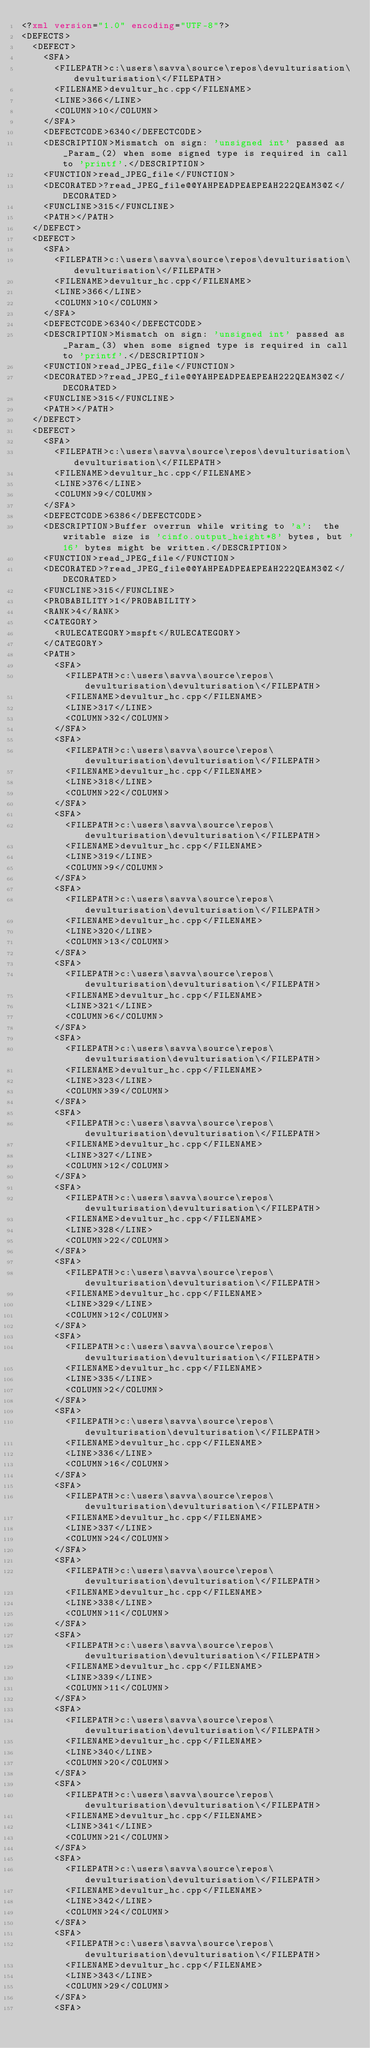<code> <loc_0><loc_0><loc_500><loc_500><_XML_><?xml version="1.0" encoding="UTF-8"?>
<DEFECTS>
  <DEFECT>
    <SFA>
      <FILEPATH>c:\users\savva\source\repos\devulturisation\devulturisation\</FILEPATH>
      <FILENAME>devultur_hc.cpp</FILENAME>
      <LINE>366</LINE>
      <COLUMN>10</COLUMN>
    </SFA>
    <DEFECTCODE>6340</DEFECTCODE>
    <DESCRIPTION>Mismatch on sign: 'unsigned int' passed as _Param_(2) when some signed type is required in call to 'printf'.</DESCRIPTION>
    <FUNCTION>read_JPEG_file</FUNCTION>
    <DECORATED>?read_JPEG_file@@YAHPEADPEAEPEAH222QEAM3@Z</DECORATED>
    <FUNCLINE>315</FUNCLINE>
    <PATH></PATH>
  </DEFECT>
  <DEFECT>
    <SFA>
      <FILEPATH>c:\users\savva\source\repos\devulturisation\devulturisation\</FILEPATH>
      <FILENAME>devultur_hc.cpp</FILENAME>
      <LINE>366</LINE>
      <COLUMN>10</COLUMN>
    </SFA>
    <DEFECTCODE>6340</DEFECTCODE>
    <DESCRIPTION>Mismatch on sign: 'unsigned int' passed as _Param_(3) when some signed type is required in call to 'printf'.</DESCRIPTION>
    <FUNCTION>read_JPEG_file</FUNCTION>
    <DECORATED>?read_JPEG_file@@YAHPEADPEAEPEAH222QEAM3@Z</DECORATED>
    <FUNCLINE>315</FUNCLINE>
    <PATH></PATH>
  </DEFECT>
  <DEFECT>
    <SFA>
      <FILEPATH>c:\users\savva\source\repos\devulturisation\devulturisation\</FILEPATH>
      <FILENAME>devultur_hc.cpp</FILENAME>
      <LINE>376</LINE>
      <COLUMN>9</COLUMN>
    </SFA>
    <DEFECTCODE>6386</DEFECTCODE>
    <DESCRIPTION>Buffer overrun while writing to 'a':  the writable size is 'cinfo.output_height*8' bytes, but '16' bytes might be written.</DESCRIPTION>
    <FUNCTION>read_JPEG_file</FUNCTION>
    <DECORATED>?read_JPEG_file@@YAHPEADPEAEPEAH222QEAM3@Z</DECORATED>
    <FUNCLINE>315</FUNCLINE>
    <PROBABILITY>1</PROBABILITY>
    <RANK>4</RANK>
    <CATEGORY>
      <RULECATEGORY>mspft</RULECATEGORY>
    </CATEGORY>
    <PATH>
      <SFA>
        <FILEPATH>c:\users\savva\source\repos\devulturisation\devulturisation\</FILEPATH>
        <FILENAME>devultur_hc.cpp</FILENAME>
        <LINE>317</LINE>
        <COLUMN>32</COLUMN>
      </SFA>
      <SFA>
        <FILEPATH>c:\users\savva\source\repos\devulturisation\devulturisation\</FILEPATH>
        <FILENAME>devultur_hc.cpp</FILENAME>
        <LINE>318</LINE>
        <COLUMN>22</COLUMN>
      </SFA>
      <SFA>
        <FILEPATH>c:\users\savva\source\repos\devulturisation\devulturisation\</FILEPATH>
        <FILENAME>devultur_hc.cpp</FILENAME>
        <LINE>319</LINE>
        <COLUMN>9</COLUMN>
      </SFA>
      <SFA>
        <FILEPATH>c:\users\savva\source\repos\devulturisation\devulturisation\</FILEPATH>
        <FILENAME>devultur_hc.cpp</FILENAME>
        <LINE>320</LINE>
        <COLUMN>13</COLUMN>
      </SFA>
      <SFA>
        <FILEPATH>c:\users\savva\source\repos\devulturisation\devulturisation\</FILEPATH>
        <FILENAME>devultur_hc.cpp</FILENAME>
        <LINE>321</LINE>
        <COLUMN>6</COLUMN>
      </SFA>
      <SFA>
        <FILEPATH>c:\users\savva\source\repos\devulturisation\devulturisation\</FILEPATH>
        <FILENAME>devultur_hc.cpp</FILENAME>
        <LINE>323</LINE>
        <COLUMN>39</COLUMN>
      </SFA>
      <SFA>
        <FILEPATH>c:\users\savva\source\repos\devulturisation\devulturisation\</FILEPATH>
        <FILENAME>devultur_hc.cpp</FILENAME>
        <LINE>327</LINE>
        <COLUMN>12</COLUMN>
      </SFA>
      <SFA>
        <FILEPATH>c:\users\savva\source\repos\devulturisation\devulturisation\</FILEPATH>
        <FILENAME>devultur_hc.cpp</FILENAME>
        <LINE>328</LINE>
        <COLUMN>22</COLUMN>
      </SFA>
      <SFA>
        <FILEPATH>c:\users\savva\source\repos\devulturisation\devulturisation\</FILEPATH>
        <FILENAME>devultur_hc.cpp</FILENAME>
        <LINE>329</LINE>
        <COLUMN>12</COLUMN>
      </SFA>
      <SFA>
        <FILEPATH>c:\users\savva\source\repos\devulturisation\devulturisation\</FILEPATH>
        <FILENAME>devultur_hc.cpp</FILENAME>
        <LINE>335</LINE>
        <COLUMN>2</COLUMN>
      </SFA>
      <SFA>
        <FILEPATH>c:\users\savva\source\repos\devulturisation\devulturisation\</FILEPATH>
        <FILENAME>devultur_hc.cpp</FILENAME>
        <LINE>336</LINE>
        <COLUMN>16</COLUMN>
      </SFA>
      <SFA>
        <FILEPATH>c:\users\savva\source\repos\devulturisation\devulturisation\</FILEPATH>
        <FILENAME>devultur_hc.cpp</FILENAME>
        <LINE>337</LINE>
        <COLUMN>24</COLUMN>
      </SFA>
      <SFA>
        <FILEPATH>c:\users\savva\source\repos\devulturisation\devulturisation\</FILEPATH>
        <FILENAME>devultur_hc.cpp</FILENAME>
        <LINE>338</LINE>
        <COLUMN>11</COLUMN>
      </SFA>
      <SFA>
        <FILEPATH>c:\users\savva\source\repos\devulturisation\devulturisation\</FILEPATH>
        <FILENAME>devultur_hc.cpp</FILENAME>
        <LINE>339</LINE>
        <COLUMN>11</COLUMN>
      </SFA>
      <SFA>
        <FILEPATH>c:\users\savva\source\repos\devulturisation\devulturisation\</FILEPATH>
        <FILENAME>devultur_hc.cpp</FILENAME>
        <LINE>340</LINE>
        <COLUMN>20</COLUMN>
      </SFA>
      <SFA>
        <FILEPATH>c:\users\savva\source\repos\devulturisation\devulturisation\</FILEPATH>
        <FILENAME>devultur_hc.cpp</FILENAME>
        <LINE>341</LINE>
        <COLUMN>21</COLUMN>
      </SFA>
      <SFA>
        <FILEPATH>c:\users\savva\source\repos\devulturisation\devulturisation\</FILEPATH>
        <FILENAME>devultur_hc.cpp</FILENAME>
        <LINE>342</LINE>
        <COLUMN>24</COLUMN>
      </SFA>
      <SFA>
        <FILEPATH>c:\users\savva\source\repos\devulturisation\devulturisation\</FILEPATH>
        <FILENAME>devultur_hc.cpp</FILENAME>
        <LINE>343</LINE>
        <COLUMN>29</COLUMN>
      </SFA>
      <SFA></code> 